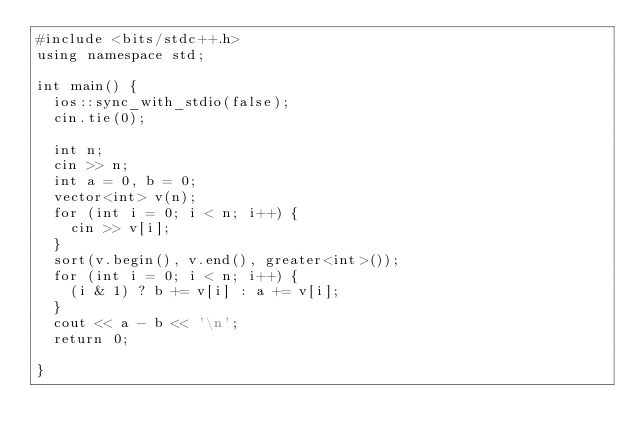Convert code to text. <code><loc_0><loc_0><loc_500><loc_500><_C++_>#include <bits/stdc++.h>
using namespace std;

int main() {
  ios::sync_with_stdio(false);
  cin.tie(0);

  int n;
  cin >> n;
  int a = 0, b = 0;
  vector<int> v(n);
  for (int i = 0; i < n; i++) {
    cin >> v[i];
  }
  sort(v.begin(), v.end(), greater<int>());
  for (int i = 0; i < n; i++) {
    (i & 1) ? b += v[i] : a += v[i];
  }
  cout << a - b << '\n';
  return 0;

}
</code> 